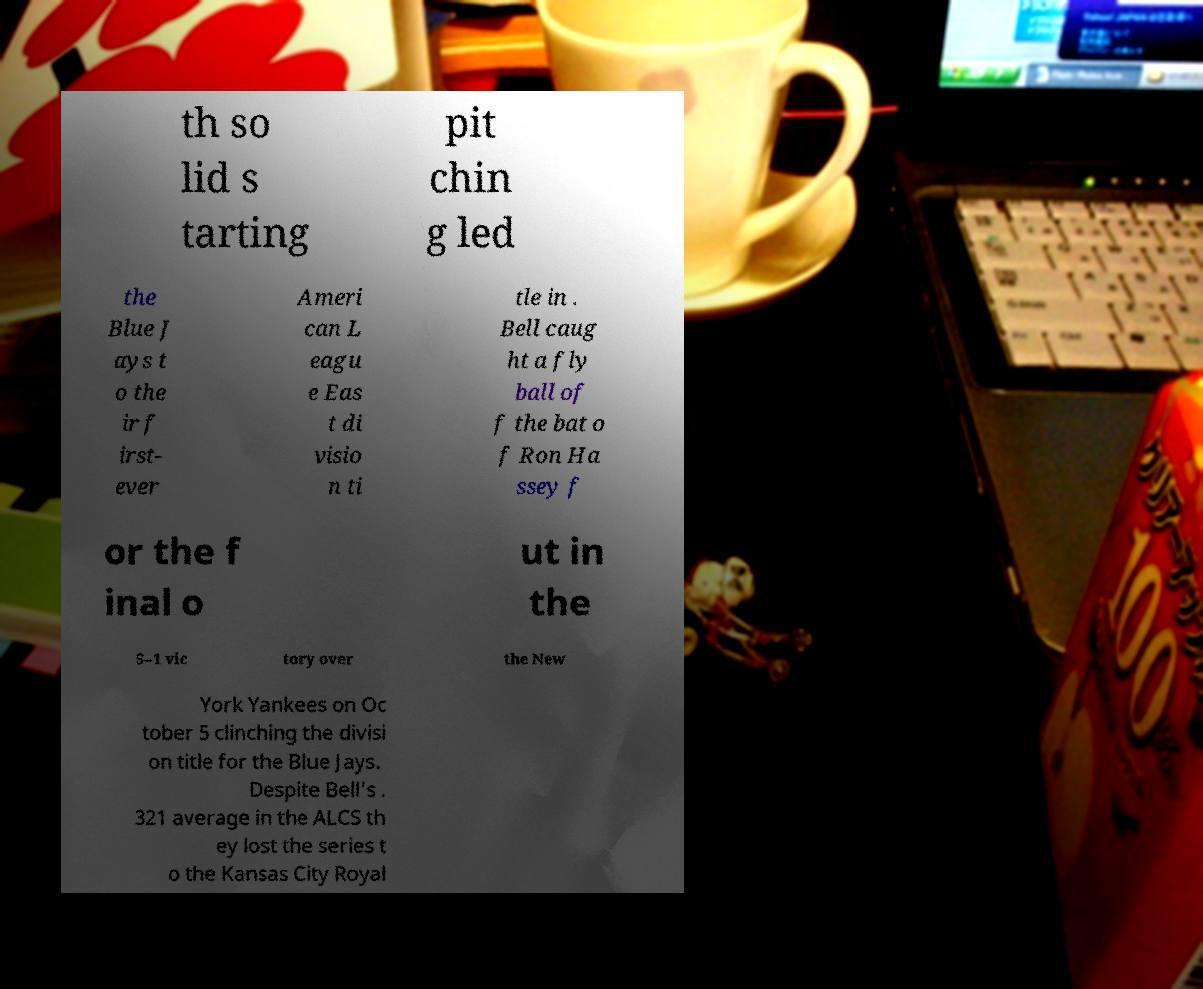For documentation purposes, I need the text within this image transcribed. Could you provide that? th so lid s tarting pit chin g led the Blue J ays t o the ir f irst- ever Ameri can L eagu e Eas t di visio n ti tle in . Bell caug ht a fly ball of f the bat o f Ron Ha ssey f or the f inal o ut in the 5–1 vic tory over the New York Yankees on Oc tober 5 clinching the divisi on title for the Blue Jays. Despite Bell's . 321 average in the ALCS th ey lost the series t o the Kansas City Royal 